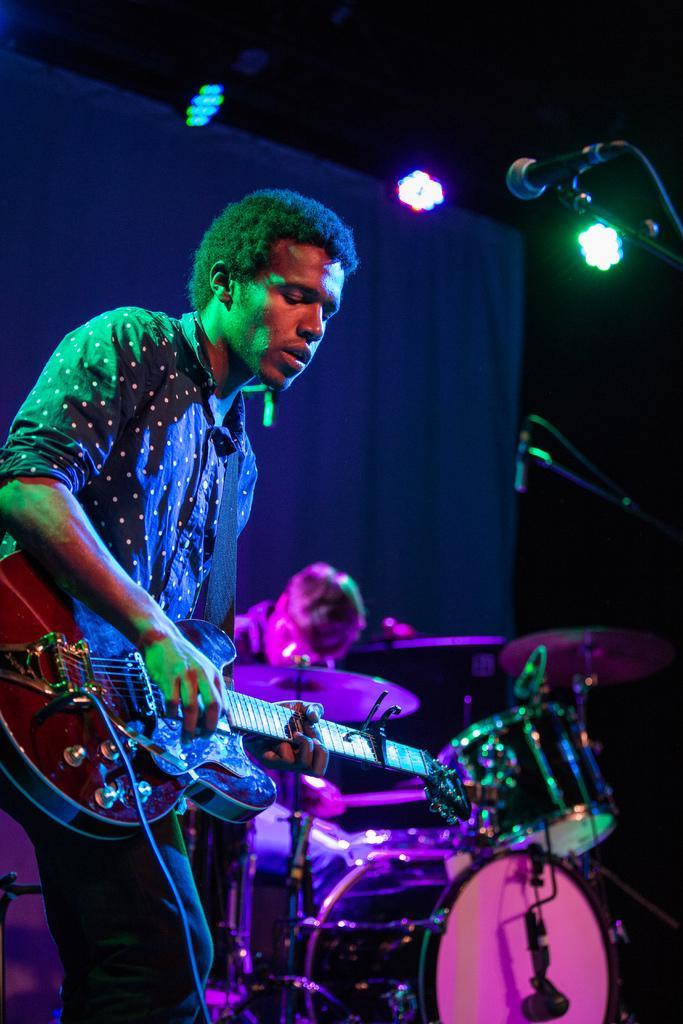How would you summarize this image in a sentence or two? As we can see in the image there are lights, mic, guitar, two persons, musical drums and the image is little dark. 